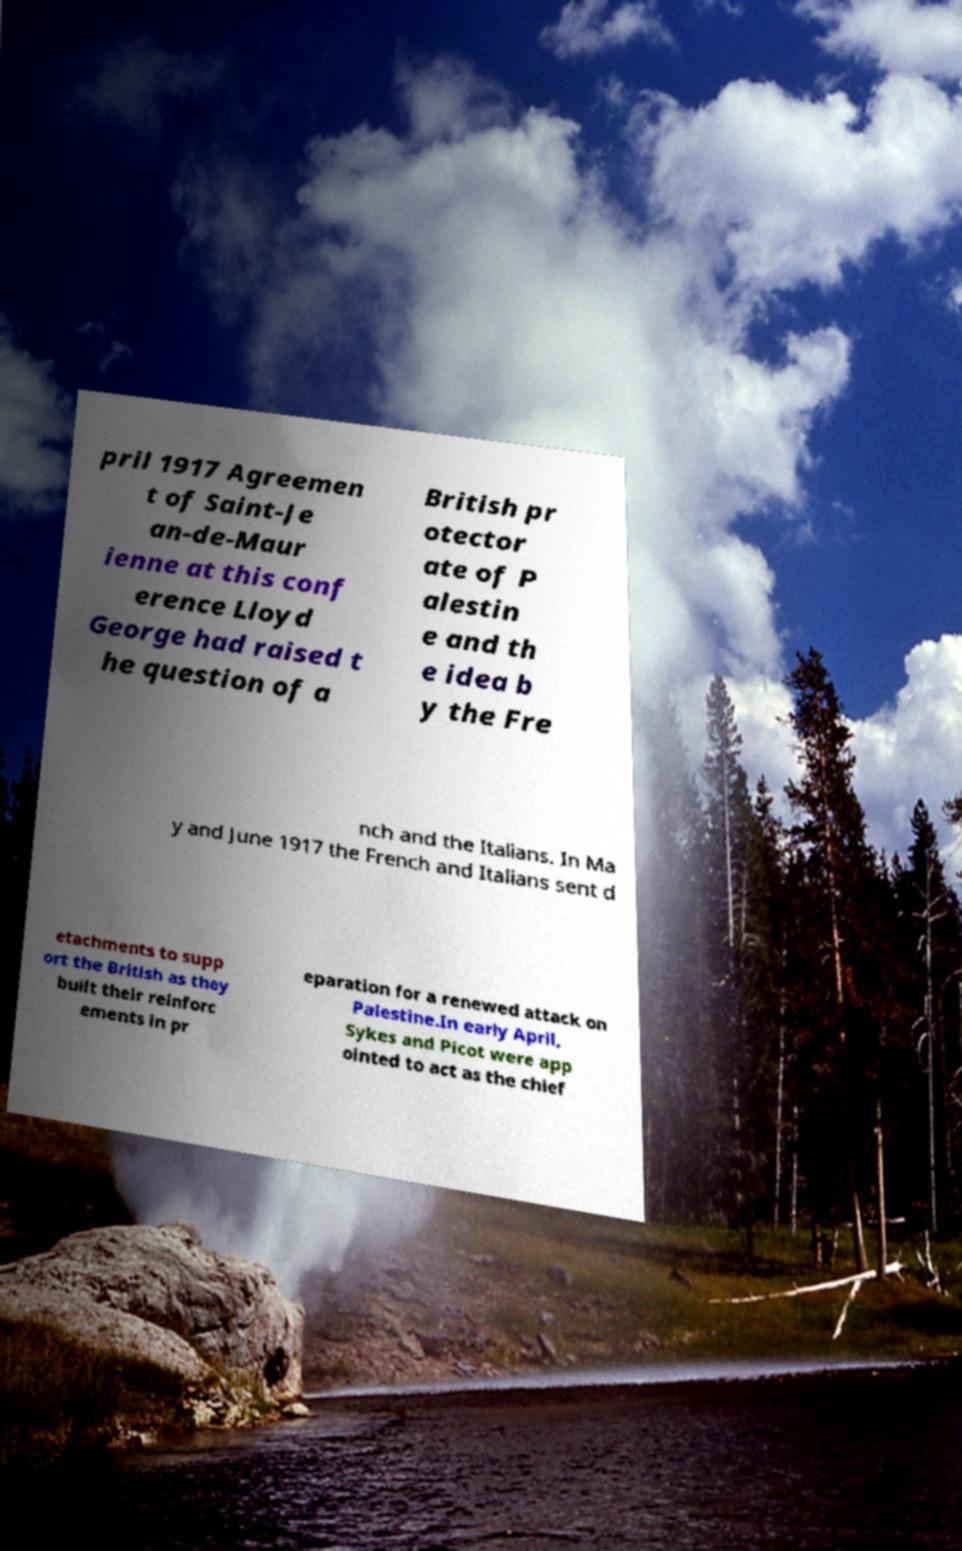What messages or text are displayed in this image? I need them in a readable, typed format. pril 1917 Agreemen t of Saint-Je an-de-Maur ienne at this conf erence Lloyd George had raised t he question of a British pr otector ate of P alestin e and th e idea b y the Fre nch and the Italians. In Ma y and June 1917 the French and Italians sent d etachments to supp ort the British as they built their reinforc ements in pr eparation for a renewed attack on Palestine.In early April, Sykes and Picot were app ointed to act as the chief 